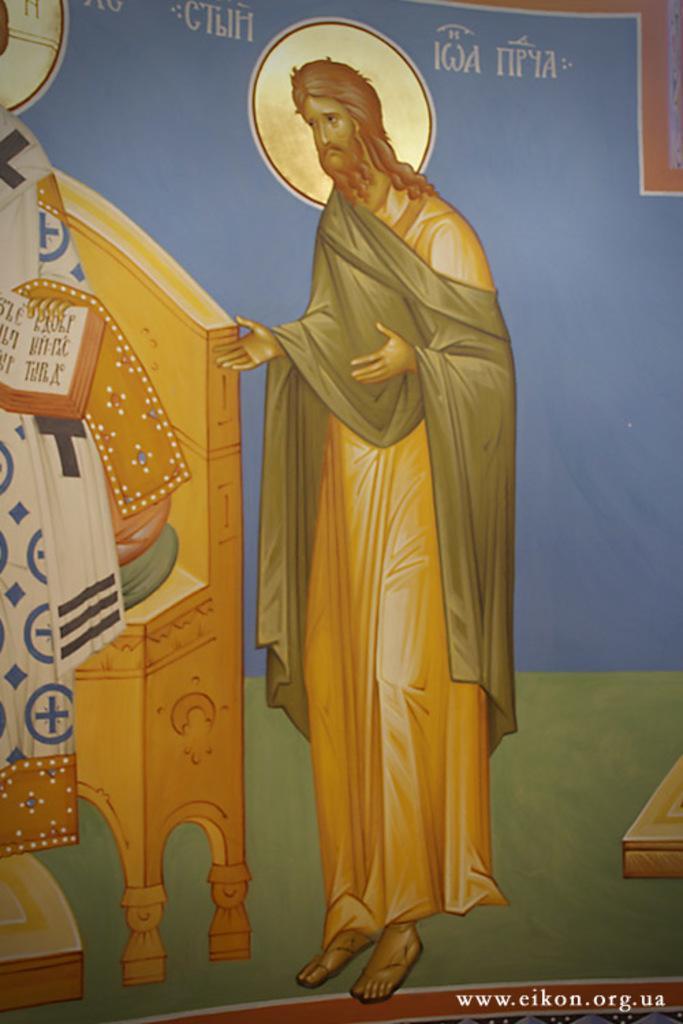Describe this image in one or two sentences. In the picture we can see a painting of a man standing near the desk. 